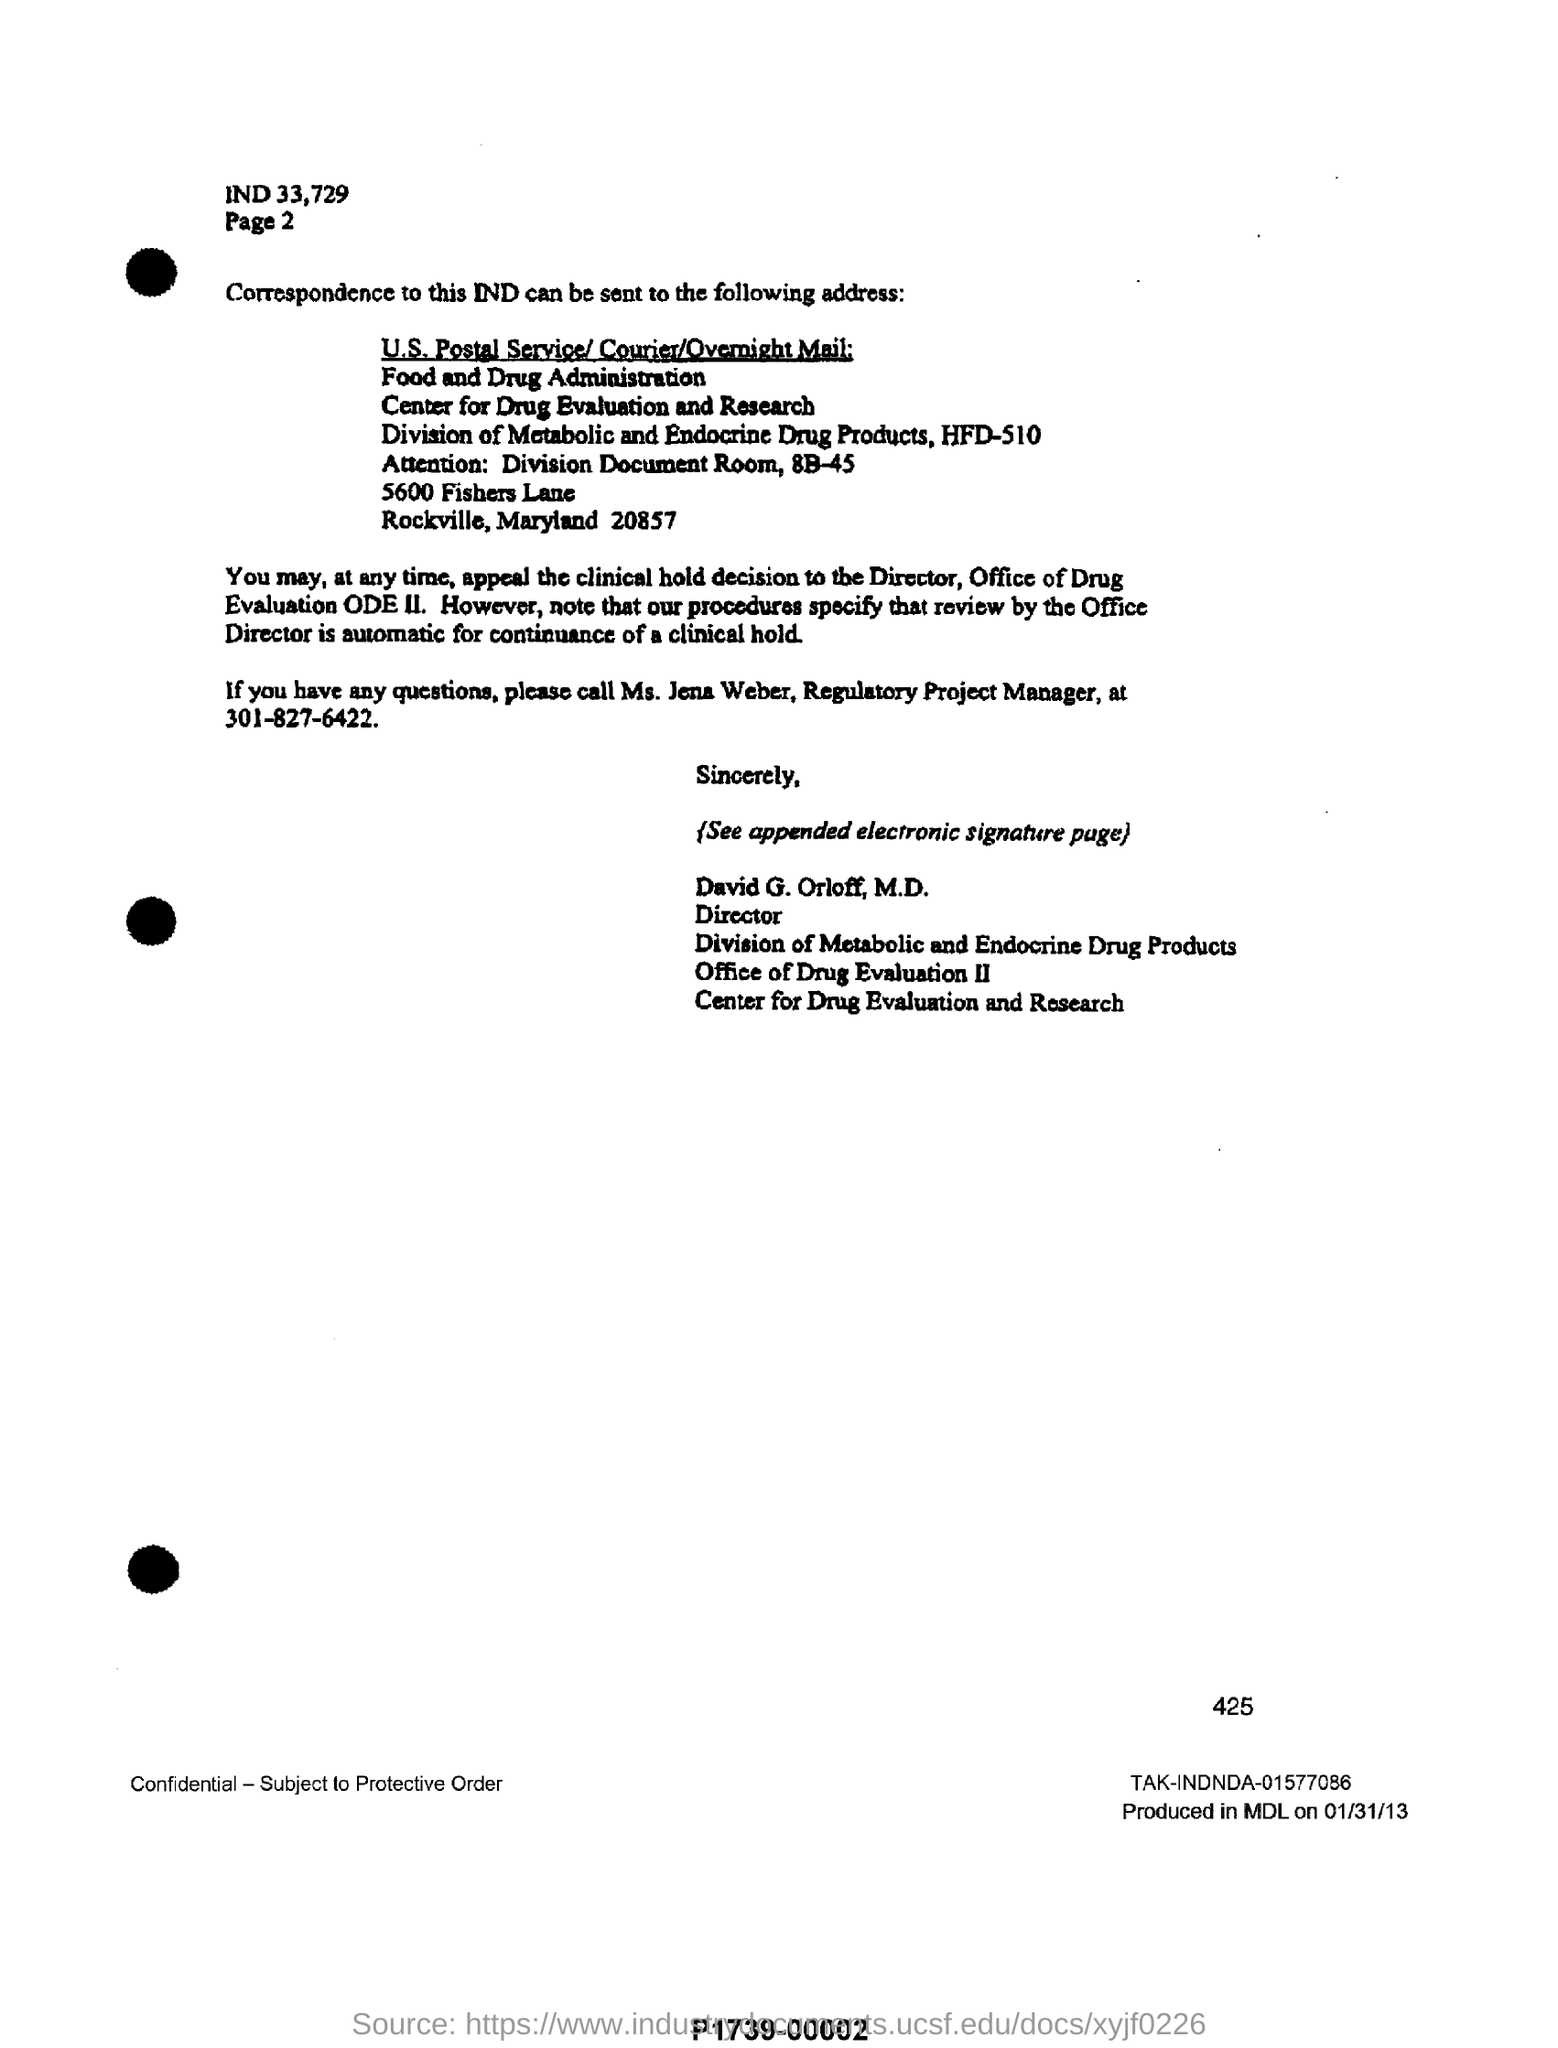Specify some key components in this picture. The full form of ODE is "Office of Drug Evaluation." This is the department responsible for evaluating and regulating the safety and efficacy of drugs in the United States. The text states that the information written above Page 2, at the top, is IND 33 and 729. The number written above TAK-INDNDA-01577086 is 425. Ms. Jena Weber, Regulatory Project Manager, can be contacted at 301-827-6422. 